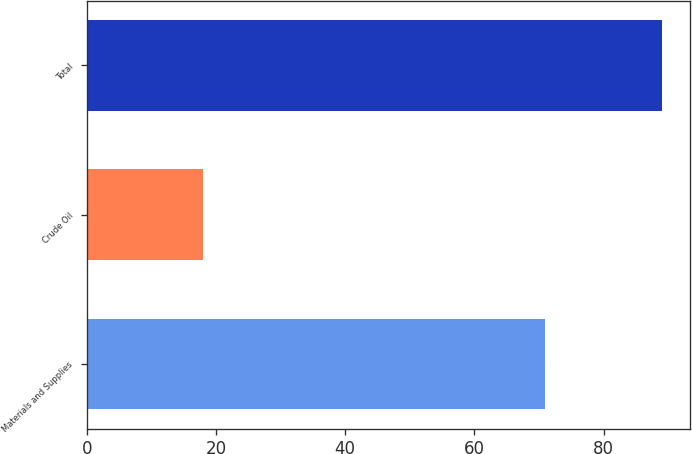Convert chart to OTSL. <chart><loc_0><loc_0><loc_500><loc_500><bar_chart><fcel>Materials and Supplies<fcel>Crude Oil<fcel>Total<nl><fcel>71<fcel>18<fcel>89<nl></chart> 